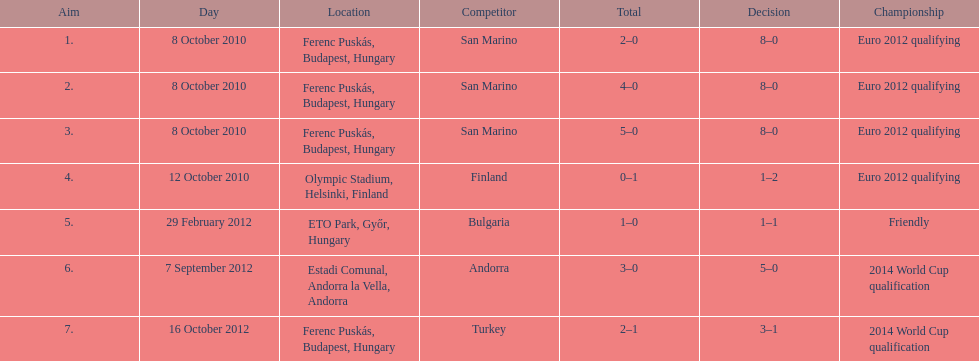Write the full table. {'header': ['Aim', 'Day', 'Location', 'Competitor', 'Total', 'Decision', 'Championship'], 'rows': [['1.', '8 October 2010', 'Ferenc Puskás, Budapest, Hungary', 'San Marino', '2–0', '8–0', 'Euro 2012 qualifying'], ['2.', '8 October 2010', 'Ferenc Puskás, Budapest, Hungary', 'San Marino', '4–0', '8–0', 'Euro 2012 qualifying'], ['3.', '8 October 2010', 'Ferenc Puskás, Budapest, Hungary', 'San Marino', '5–0', '8–0', 'Euro 2012 qualifying'], ['4.', '12 October 2010', 'Olympic Stadium, Helsinki, Finland', 'Finland', '0–1', '1–2', 'Euro 2012 qualifying'], ['5.', '29 February 2012', 'ETO Park, Győr, Hungary', 'Bulgaria', '1–0', '1–1', 'Friendly'], ['6.', '7 September 2012', 'Estadi Comunal, Andorra la Vella, Andorra', 'Andorra', '3–0', '5–0', '2014 World Cup qualification'], ['7.', '16 October 2012', 'Ferenc Puskás, Budapest, Hungary', 'Turkey', '2–1', '3–1', '2014 World Cup qualification']]} What is the total number of international goals ádám szalai has made? 7. 